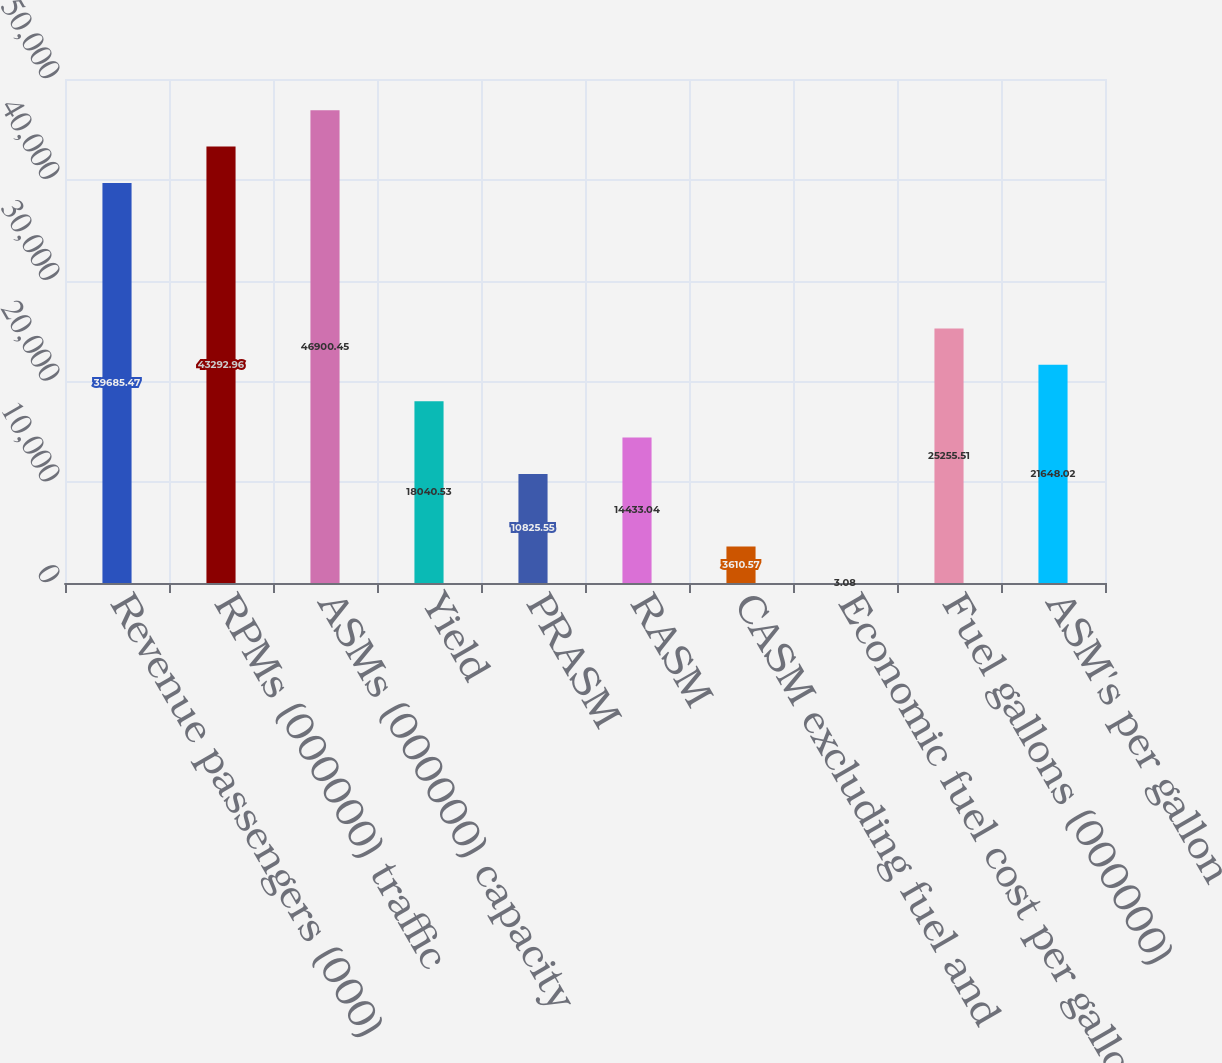Convert chart. <chart><loc_0><loc_0><loc_500><loc_500><bar_chart><fcel>Revenue passengers (000)<fcel>RPMs (000000) traffic<fcel>ASMs (000000) capacity<fcel>Yield<fcel>PRASM<fcel>RASM<fcel>CASM excluding fuel and<fcel>Economic fuel cost per gallon<fcel>Fuel gallons (000000)<fcel>ASM's per gallon<nl><fcel>39685.5<fcel>43293<fcel>46900.4<fcel>18040.5<fcel>10825.5<fcel>14433<fcel>3610.57<fcel>3.08<fcel>25255.5<fcel>21648<nl></chart> 